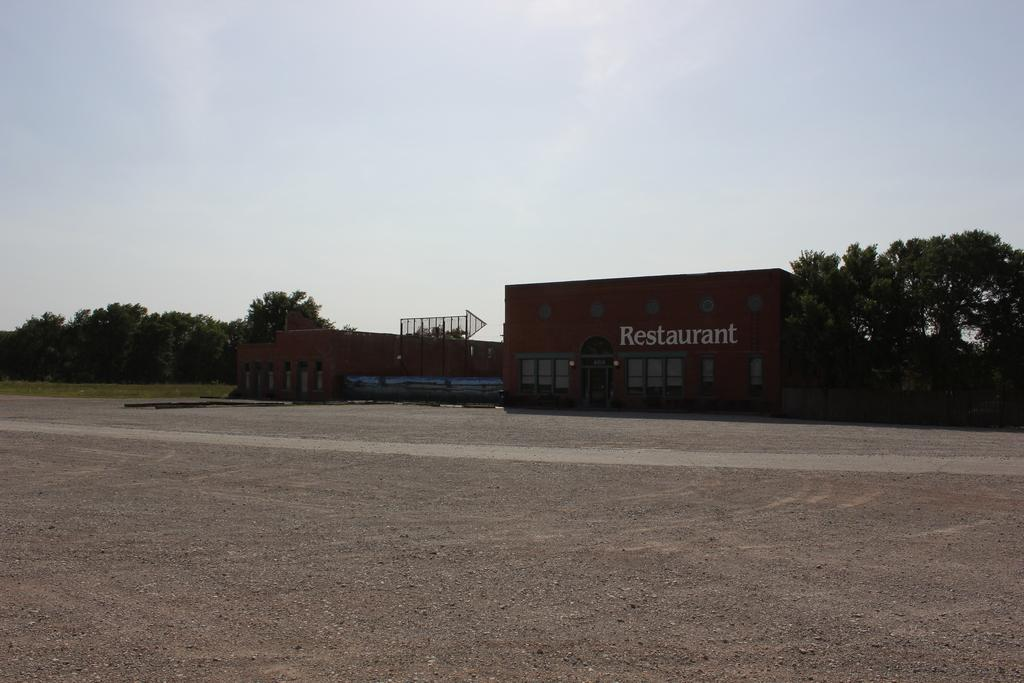What type of structures can be seen in the image? There are houses in the image. What is written or displayed on a wall in the image? There is text on a wall in the image. What part of the natural environment is visible in the image? The sky is visible in the image. What type of vegetation is present in the image? There are trees in the image. What type of dock can be seen in the image? There is no dock present in the image. What is the function of the home in the image? The image does not provide information about the function of the houses; it only shows their presence. 